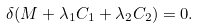Convert formula to latex. <formula><loc_0><loc_0><loc_500><loc_500>\delta ( M + \lambda _ { 1 } C _ { 1 } + \lambda _ { 2 } C _ { 2 } ) = 0 .</formula> 